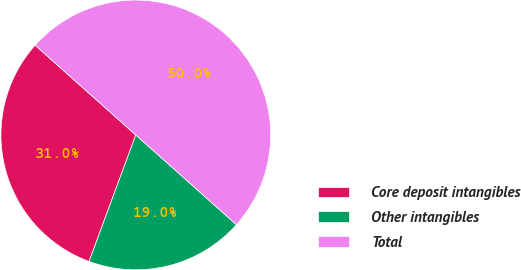<chart> <loc_0><loc_0><loc_500><loc_500><pie_chart><fcel>Core deposit intangibles<fcel>Other intangibles<fcel>Total<nl><fcel>30.96%<fcel>19.04%<fcel>50.0%<nl></chart> 